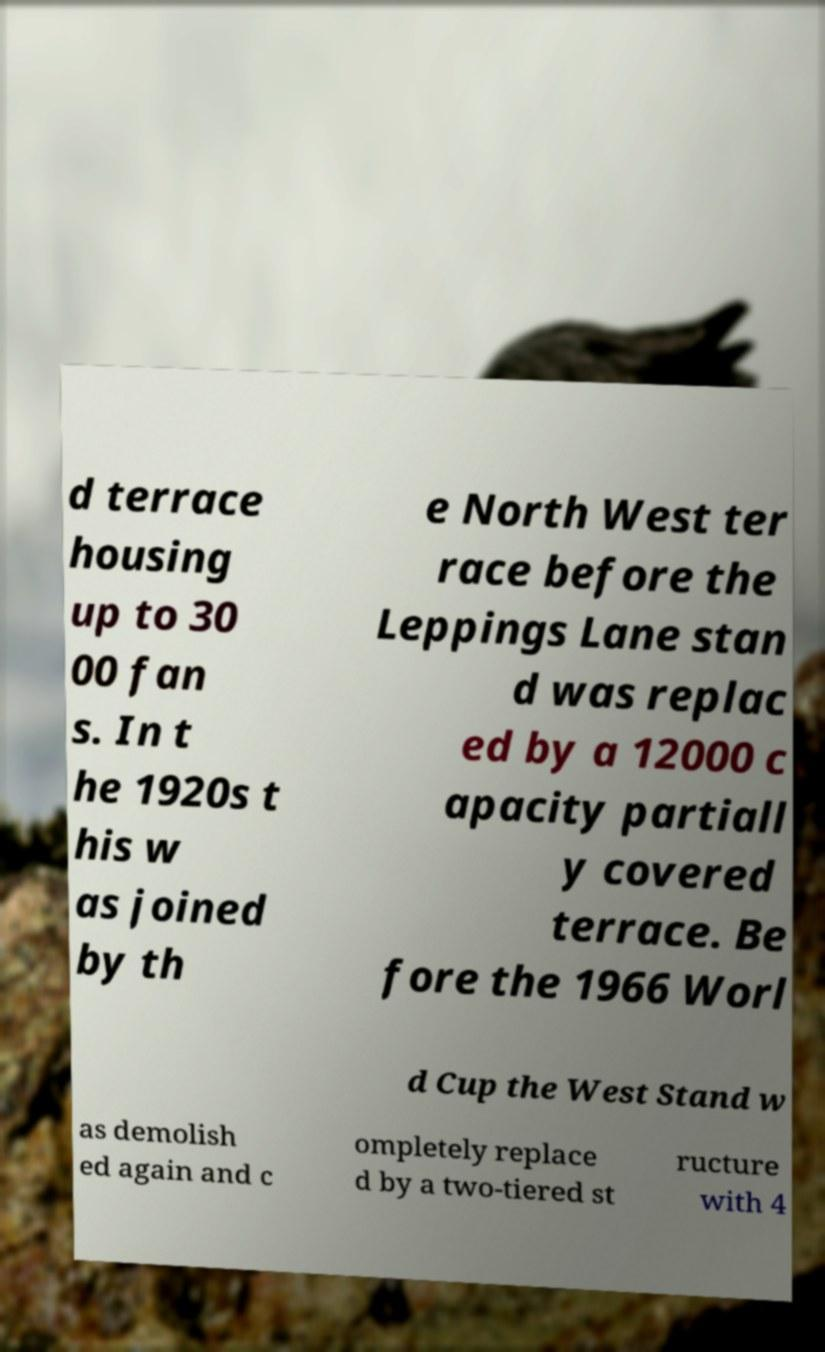For documentation purposes, I need the text within this image transcribed. Could you provide that? d terrace housing up to 30 00 fan s. In t he 1920s t his w as joined by th e North West ter race before the Leppings Lane stan d was replac ed by a 12000 c apacity partiall y covered terrace. Be fore the 1966 Worl d Cup the West Stand w as demolish ed again and c ompletely replace d by a two-tiered st ructure with 4 